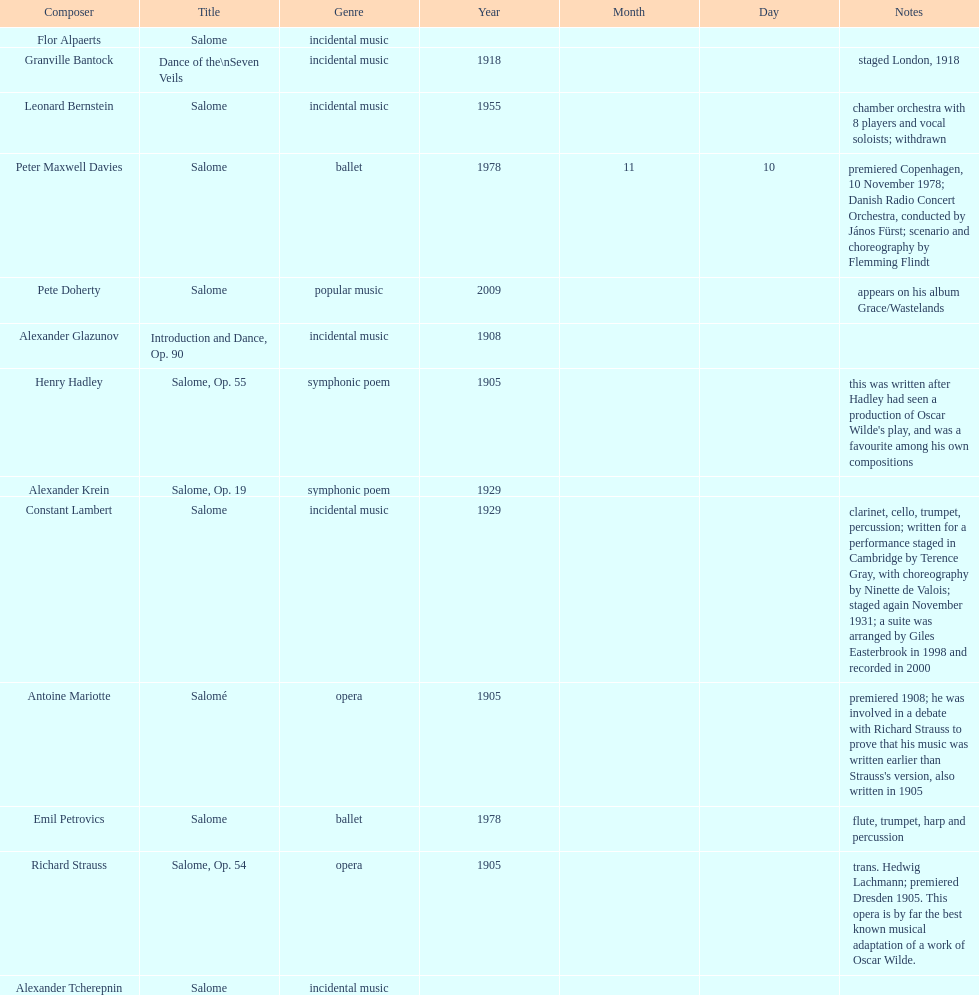Who is on top of the list? Flor Alpaerts. 